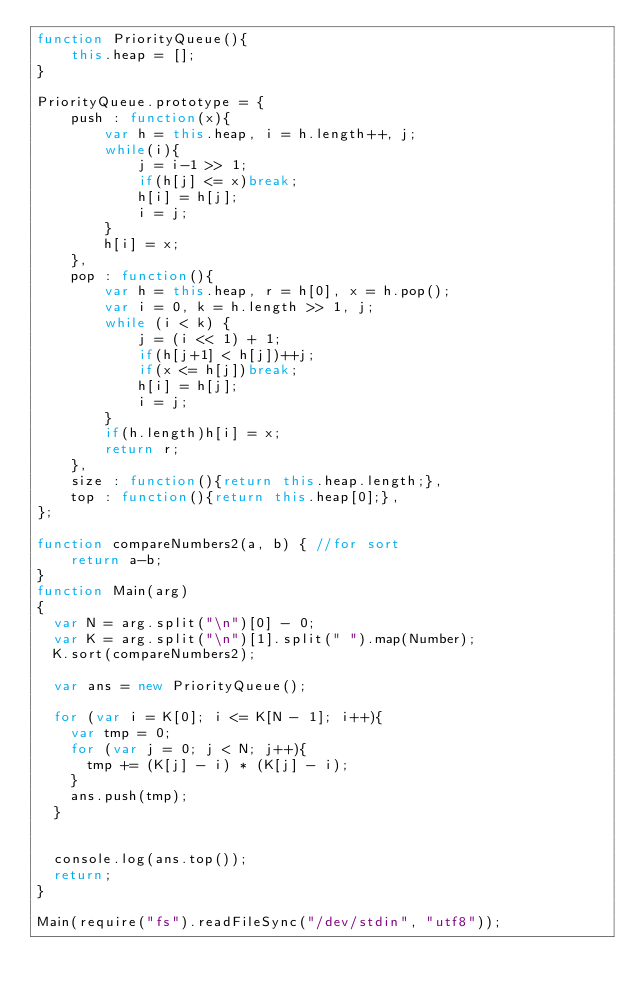<code> <loc_0><loc_0><loc_500><loc_500><_JavaScript_>function PriorityQueue(){
    this.heap = [];
}

PriorityQueue.prototype = {
    push : function(x){
        var h = this.heap, i = h.length++, j;
        while(i){
            j = i-1 >> 1;
            if(h[j] <= x)break;
            h[i] = h[j];
            i = j;
        }
        h[i] = x;
    },
    pop : function(){
        var h = this.heap, r = h[0], x = h.pop();
        var i = 0, k = h.length >> 1, j;
        while (i < k) {
            j = (i << 1) + 1;
            if(h[j+1] < h[j])++j;
            if(x <= h[j])break;
            h[i] = h[j];
            i = j;
        }
        if(h.length)h[i] = x;
        return r;
    },
    size : function(){return this.heap.length;},
    top : function(){return this.heap[0];},
};

function compareNumbers2(a, b) { //for sort
    return a-b;
}
function Main(arg)
{
  var N = arg.split("\n")[0] - 0;
  var K = arg.split("\n")[1].split(" ").map(Number);
  K.sort(compareNumbers2);

  var ans = new PriorityQueue();

  for (var i = K[0]; i <= K[N - 1]; i++){
    var tmp = 0;
    for (var j = 0; j < N; j++){
      tmp += (K[j] - i) * (K[j] - i);
    }
    ans.push(tmp);
  }


  console.log(ans.top());
  return;
}

Main(require("fs").readFileSync("/dev/stdin", "utf8"));
</code> 